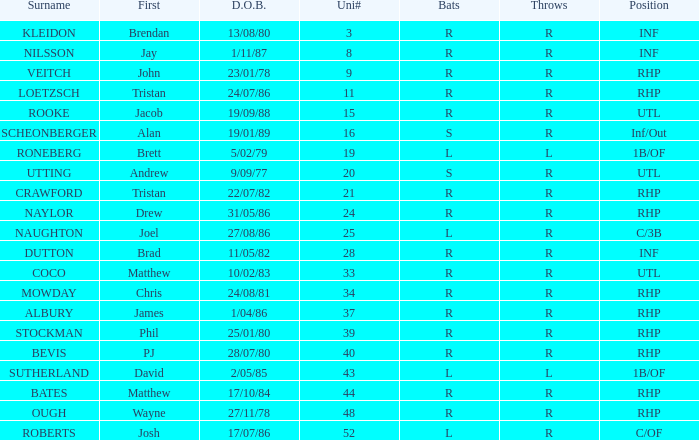Which Surname has Throws of l, and a DOB of 5/02/79? RONEBERG. 